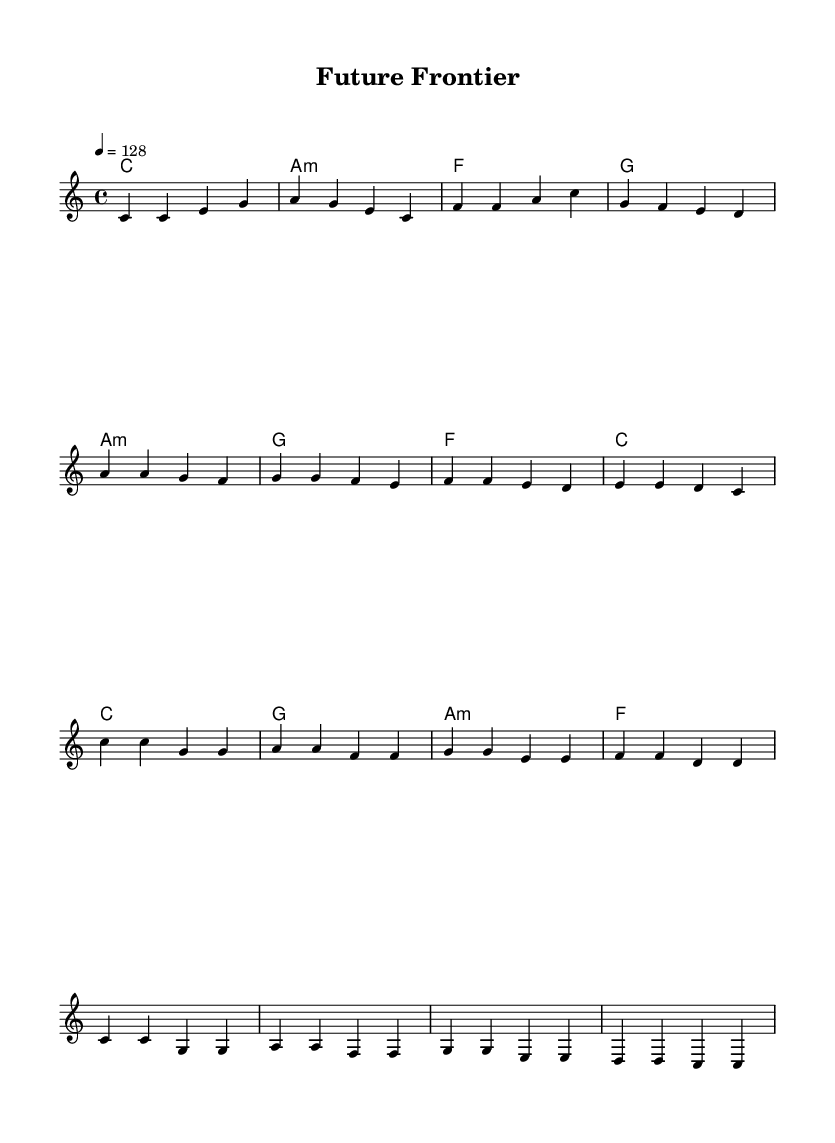What is the key signature of this music? The key signature is indicated at the beginning of the score. It shows no sharps or flats which signifies a C major key.
Answer: C major What is the time signature of this music? The time signature is found at the beginning of the score, showing a 4/4, which means there are four beats per measure.
Answer: 4/4 What is the tempo marking for this piece? The tempo is indicated above the staff, showing a metronome marking of 128 beats per minute, which is relatively fast for a pop anthem.
Answer: 128 How many measures are present in the verse section? The verse is represented at the start of the melody section. Counting the measures based on the notation shows there are 4 measures in the verse.
Answer: 4 What is the first chord of the chorus? The first chord in the chorus section is found in the chord mode notation and is labeled as 'C' indicating the chord played at that moment.
Answer: C Which section follows the verse? The structure of the piece is indicated by the ordering of the sections, where the melody moves from the verse to the pre-chorus, as noted by the progression pattern.
Answer: Pre-Chorus What is the mood conveyed by this song based on its structure? The song has an energetic and uplifting mood based on the tempo (128 bpm) and the celebratory phrasing typical of pop anthems centered around scientific themes.
Answer: Energetic 